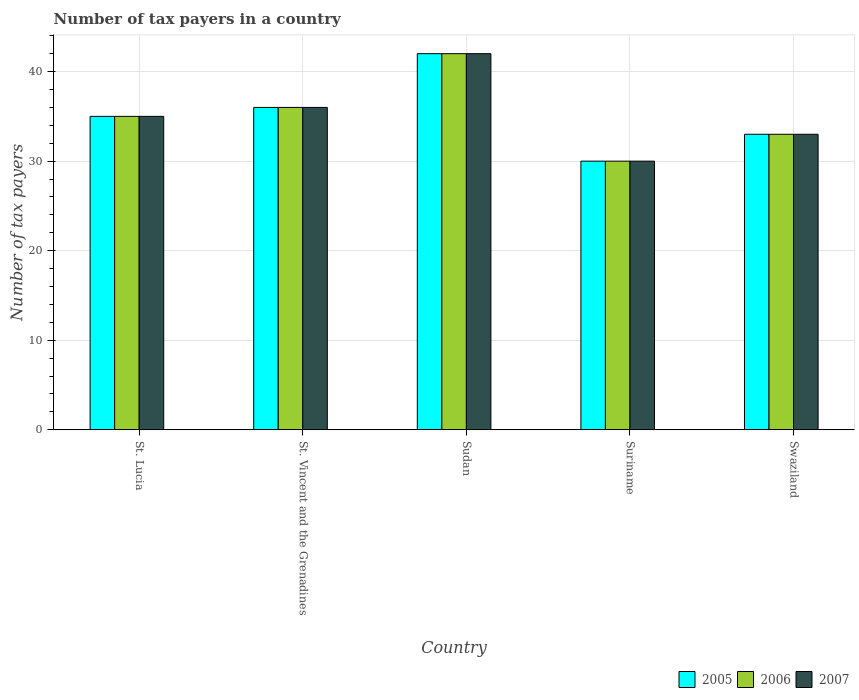How many different coloured bars are there?
Provide a succinct answer. 3. Are the number of bars on each tick of the X-axis equal?
Make the answer very short. Yes. How many bars are there on the 1st tick from the left?
Provide a short and direct response. 3. What is the label of the 4th group of bars from the left?
Ensure brevity in your answer.  Suriname. What is the number of tax payers in in 2007 in St. Lucia?
Offer a terse response. 35. Across all countries, what is the minimum number of tax payers in in 2006?
Provide a short and direct response. 30. In which country was the number of tax payers in in 2005 maximum?
Provide a short and direct response. Sudan. In which country was the number of tax payers in in 2006 minimum?
Provide a short and direct response. Suriname. What is the total number of tax payers in in 2006 in the graph?
Offer a very short reply. 176. What is the difference between the number of tax payers in in 2007 in St. Vincent and the Grenadines and that in Swaziland?
Keep it short and to the point. 3. What is the average number of tax payers in in 2006 per country?
Provide a succinct answer. 35.2. What is the ratio of the number of tax payers in in 2005 in St. Lucia to that in Sudan?
Make the answer very short. 0.83. Is the number of tax payers in in 2006 in St. Lucia less than that in Sudan?
Give a very brief answer. Yes. What is the difference between the highest and the second highest number of tax payers in in 2006?
Your answer should be very brief. 7. Is the sum of the number of tax payers in in 2005 in Suriname and Swaziland greater than the maximum number of tax payers in in 2007 across all countries?
Provide a short and direct response. Yes. What does the 2nd bar from the right in Suriname represents?
Your answer should be very brief. 2006. How many countries are there in the graph?
Your answer should be compact. 5. Are the values on the major ticks of Y-axis written in scientific E-notation?
Give a very brief answer. No. Does the graph contain grids?
Your response must be concise. Yes. How many legend labels are there?
Your answer should be compact. 3. What is the title of the graph?
Provide a succinct answer. Number of tax payers in a country. What is the label or title of the X-axis?
Your response must be concise. Country. What is the label or title of the Y-axis?
Give a very brief answer. Number of tax payers. What is the Number of tax payers of 2005 in St. Lucia?
Offer a very short reply. 35. What is the Number of tax payers in 2006 in St. Lucia?
Make the answer very short. 35. What is the Number of tax payers of 2005 in St. Vincent and the Grenadines?
Make the answer very short. 36. What is the Number of tax payers in 2006 in St. Vincent and the Grenadines?
Make the answer very short. 36. What is the Number of tax payers of 2007 in St. Vincent and the Grenadines?
Make the answer very short. 36. What is the Number of tax payers in 2006 in Sudan?
Your answer should be very brief. 42. What is the Number of tax payers of 2007 in Sudan?
Your response must be concise. 42. What is the Number of tax payers in 2005 in Suriname?
Your answer should be very brief. 30. What is the Number of tax payers of 2006 in Suriname?
Provide a succinct answer. 30. What is the Number of tax payers of 2005 in Swaziland?
Your response must be concise. 33. What is the Number of tax payers of 2006 in Swaziland?
Provide a short and direct response. 33. What is the Number of tax payers in 2007 in Swaziland?
Ensure brevity in your answer.  33. Across all countries, what is the maximum Number of tax payers of 2005?
Your response must be concise. 42. Across all countries, what is the maximum Number of tax payers of 2006?
Provide a short and direct response. 42. Across all countries, what is the maximum Number of tax payers in 2007?
Make the answer very short. 42. Across all countries, what is the minimum Number of tax payers of 2005?
Your answer should be compact. 30. Across all countries, what is the minimum Number of tax payers of 2007?
Your answer should be very brief. 30. What is the total Number of tax payers of 2005 in the graph?
Your response must be concise. 176. What is the total Number of tax payers of 2006 in the graph?
Provide a succinct answer. 176. What is the total Number of tax payers of 2007 in the graph?
Offer a terse response. 176. What is the difference between the Number of tax payers of 2005 in St. Lucia and that in St. Vincent and the Grenadines?
Offer a very short reply. -1. What is the difference between the Number of tax payers in 2006 in St. Lucia and that in St. Vincent and the Grenadines?
Keep it short and to the point. -1. What is the difference between the Number of tax payers in 2005 in St. Lucia and that in Sudan?
Your answer should be very brief. -7. What is the difference between the Number of tax payers of 2006 in St. Lucia and that in Sudan?
Your answer should be compact. -7. What is the difference between the Number of tax payers in 2007 in St. Lucia and that in Sudan?
Your answer should be very brief. -7. What is the difference between the Number of tax payers of 2006 in St. Lucia and that in Suriname?
Provide a succinct answer. 5. What is the difference between the Number of tax payers in 2007 in St. Lucia and that in Suriname?
Give a very brief answer. 5. What is the difference between the Number of tax payers in 2005 in St. Lucia and that in Swaziland?
Your response must be concise. 2. What is the difference between the Number of tax payers of 2007 in St. Lucia and that in Swaziland?
Your answer should be very brief. 2. What is the difference between the Number of tax payers of 2007 in St. Vincent and the Grenadines and that in Sudan?
Ensure brevity in your answer.  -6. What is the difference between the Number of tax payers of 2005 in St. Vincent and the Grenadines and that in Suriname?
Your answer should be very brief. 6. What is the difference between the Number of tax payers of 2006 in St. Vincent and the Grenadines and that in Suriname?
Provide a short and direct response. 6. What is the difference between the Number of tax payers of 2005 in St. Vincent and the Grenadines and that in Swaziland?
Make the answer very short. 3. What is the difference between the Number of tax payers of 2006 in St. Vincent and the Grenadines and that in Swaziland?
Give a very brief answer. 3. What is the difference between the Number of tax payers of 2005 in Sudan and that in Swaziland?
Offer a very short reply. 9. What is the difference between the Number of tax payers of 2006 in Suriname and that in Swaziland?
Keep it short and to the point. -3. What is the difference between the Number of tax payers in 2005 in St. Lucia and the Number of tax payers in 2006 in St. Vincent and the Grenadines?
Your answer should be very brief. -1. What is the difference between the Number of tax payers in 2005 in St. Lucia and the Number of tax payers in 2006 in Sudan?
Your response must be concise. -7. What is the difference between the Number of tax payers of 2005 in St. Lucia and the Number of tax payers of 2007 in Sudan?
Ensure brevity in your answer.  -7. What is the difference between the Number of tax payers in 2006 in St. Lucia and the Number of tax payers in 2007 in Sudan?
Keep it short and to the point. -7. What is the difference between the Number of tax payers in 2005 in St. Lucia and the Number of tax payers in 2006 in Suriname?
Your answer should be compact. 5. What is the difference between the Number of tax payers in 2005 in St. Lucia and the Number of tax payers in 2007 in Suriname?
Offer a very short reply. 5. What is the difference between the Number of tax payers in 2006 in St. Lucia and the Number of tax payers in 2007 in Suriname?
Make the answer very short. 5. What is the difference between the Number of tax payers in 2006 in St. Lucia and the Number of tax payers in 2007 in Swaziland?
Offer a terse response. 2. What is the difference between the Number of tax payers of 2005 in St. Vincent and the Grenadines and the Number of tax payers of 2007 in Sudan?
Provide a short and direct response. -6. What is the difference between the Number of tax payers in 2006 in St. Vincent and the Grenadines and the Number of tax payers in 2007 in Sudan?
Provide a succinct answer. -6. What is the difference between the Number of tax payers of 2005 in St. Vincent and the Grenadines and the Number of tax payers of 2007 in Suriname?
Ensure brevity in your answer.  6. What is the difference between the Number of tax payers in 2006 in St. Vincent and the Grenadines and the Number of tax payers in 2007 in Suriname?
Offer a very short reply. 6. What is the difference between the Number of tax payers in 2005 in St. Vincent and the Grenadines and the Number of tax payers in 2007 in Swaziland?
Offer a terse response. 3. What is the difference between the Number of tax payers in 2006 in St. Vincent and the Grenadines and the Number of tax payers in 2007 in Swaziland?
Your answer should be compact. 3. What is the difference between the Number of tax payers in 2005 in Sudan and the Number of tax payers in 2006 in Suriname?
Offer a very short reply. 12. What is the difference between the Number of tax payers of 2005 in Sudan and the Number of tax payers of 2007 in Suriname?
Give a very brief answer. 12. What is the difference between the Number of tax payers of 2005 in Sudan and the Number of tax payers of 2006 in Swaziland?
Provide a short and direct response. 9. What is the difference between the Number of tax payers of 2006 in Sudan and the Number of tax payers of 2007 in Swaziland?
Your response must be concise. 9. What is the difference between the Number of tax payers in 2005 in Suriname and the Number of tax payers in 2007 in Swaziland?
Your answer should be compact. -3. What is the average Number of tax payers in 2005 per country?
Your answer should be compact. 35.2. What is the average Number of tax payers in 2006 per country?
Offer a terse response. 35.2. What is the average Number of tax payers in 2007 per country?
Ensure brevity in your answer.  35.2. What is the difference between the Number of tax payers in 2005 and Number of tax payers in 2006 in St. Vincent and the Grenadines?
Offer a very short reply. 0. What is the difference between the Number of tax payers of 2005 and Number of tax payers of 2007 in St. Vincent and the Grenadines?
Provide a short and direct response. 0. What is the difference between the Number of tax payers of 2005 and Number of tax payers of 2007 in Sudan?
Your answer should be compact. 0. What is the difference between the Number of tax payers in 2005 and Number of tax payers in 2006 in Suriname?
Your answer should be compact. 0. What is the difference between the Number of tax payers of 2006 and Number of tax payers of 2007 in Suriname?
Your response must be concise. 0. What is the difference between the Number of tax payers of 2005 and Number of tax payers of 2006 in Swaziland?
Give a very brief answer. 0. What is the difference between the Number of tax payers in 2005 and Number of tax payers in 2007 in Swaziland?
Make the answer very short. 0. What is the difference between the Number of tax payers in 2006 and Number of tax payers in 2007 in Swaziland?
Ensure brevity in your answer.  0. What is the ratio of the Number of tax payers in 2005 in St. Lucia to that in St. Vincent and the Grenadines?
Your answer should be compact. 0.97. What is the ratio of the Number of tax payers of 2006 in St. Lucia to that in St. Vincent and the Grenadines?
Give a very brief answer. 0.97. What is the ratio of the Number of tax payers of 2007 in St. Lucia to that in St. Vincent and the Grenadines?
Give a very brief answer. 0.97. What is the ratio of the Number of tax payers of 2005 in St. Lucia to that in Sudan?
Your answer should be very brief. 0.83. What is the ratio of the Number of tax payers of 2007 in St. Lucia to that in Sudan?
Make the answer very short. 0.83. What is the ratio of the Number of tax payers of 2005 in St. Lucia to that in Suriname?
Provide a succinct answer. 1.17. What is the ratio of the Number of tax payers in 2006 in St. Lucia to that in Suriname?
Your answer should be very brief. 1.17. What is the ratio of the Number of tax payers in 2005 in St. Lucia to that in Swaziland?
Make the answer very short. 1.06. What is the ratio of the Number of tax payers of 2006 in St. Lucia to that in Swaziland?
Your response must be concise. 1.06. What is the ratio of the Number of tax payers of 2007 in St. Lucia to that in Swaziland?
Your response must be concise. 1.06. What is the ratio of the Number of tax payers of 2005 in St. Vincent and the Grenadines to that in Sudan?
Your response must be concise. 0.86. What is the ratio of the Number of tax payers in 2006 in St. Vincent and the Grenadines to that in Sudan?
Give a very brief answer. 0.86. What is the ratio of the Number of tax payers in 2005 in St. Vincent and the Grenadines to that in Suriname?
Provide a short and direct response. 1.2. What is the ratio of the Number of tax payers in 2006 in St. Vincent and the Grenadines to that in Suriname?
Ensure brevity in your answer.  1.2. What is the ratio of the Number of tax payers in 2007 in St. Vincent and the Grenadines to that in Swaziland?
Your answer should be compact. 1.09. What is the ratio of the Number of tax payers in 2005 in Sudan to that in Suriname?
Offer a terse response. 1.4. What is the ratio of the Number of tax payers of 2006 in Sudan to that in Suriname?
Your answer should be compact. 1.4. What is the ratio of the Number of tax payers of 2005 in Sudan to that in Swaziland?
Your answer should be compact. 1.27. What is the ratio of the Number of tax payers of 2006 in Sudan to that in Swaziland?
Your response must be concise. 1.27. What is the ratio of the Number of tax payers of 2007 in Sudan to that in Swaziland?
Ensure brevity in your answer.  1.27. What is the ratio of the Number of tax payers of 2005 in Suriname to that in Swaziland?
Keep it short and to the point. 0.91. What is the ratio of the Number of tax payers in 2007 in Suriname to that in Swaziland?
Provide a succinct answer. 0.91. What is the difference between the highest and the second highest Number of tax payers in 2005?
Your answer should be compact. 6. What is the difference between the highest and the second highest Number of tax payers in 2006?
Offer a terse response. 6. What is the difference between the highest and the second highest Number of tax payers in 2007?
Make the answer very short. 6. What is the difference between the highest and the lowest Number of tax payers of 2006?
Offer a terse response. 12. 